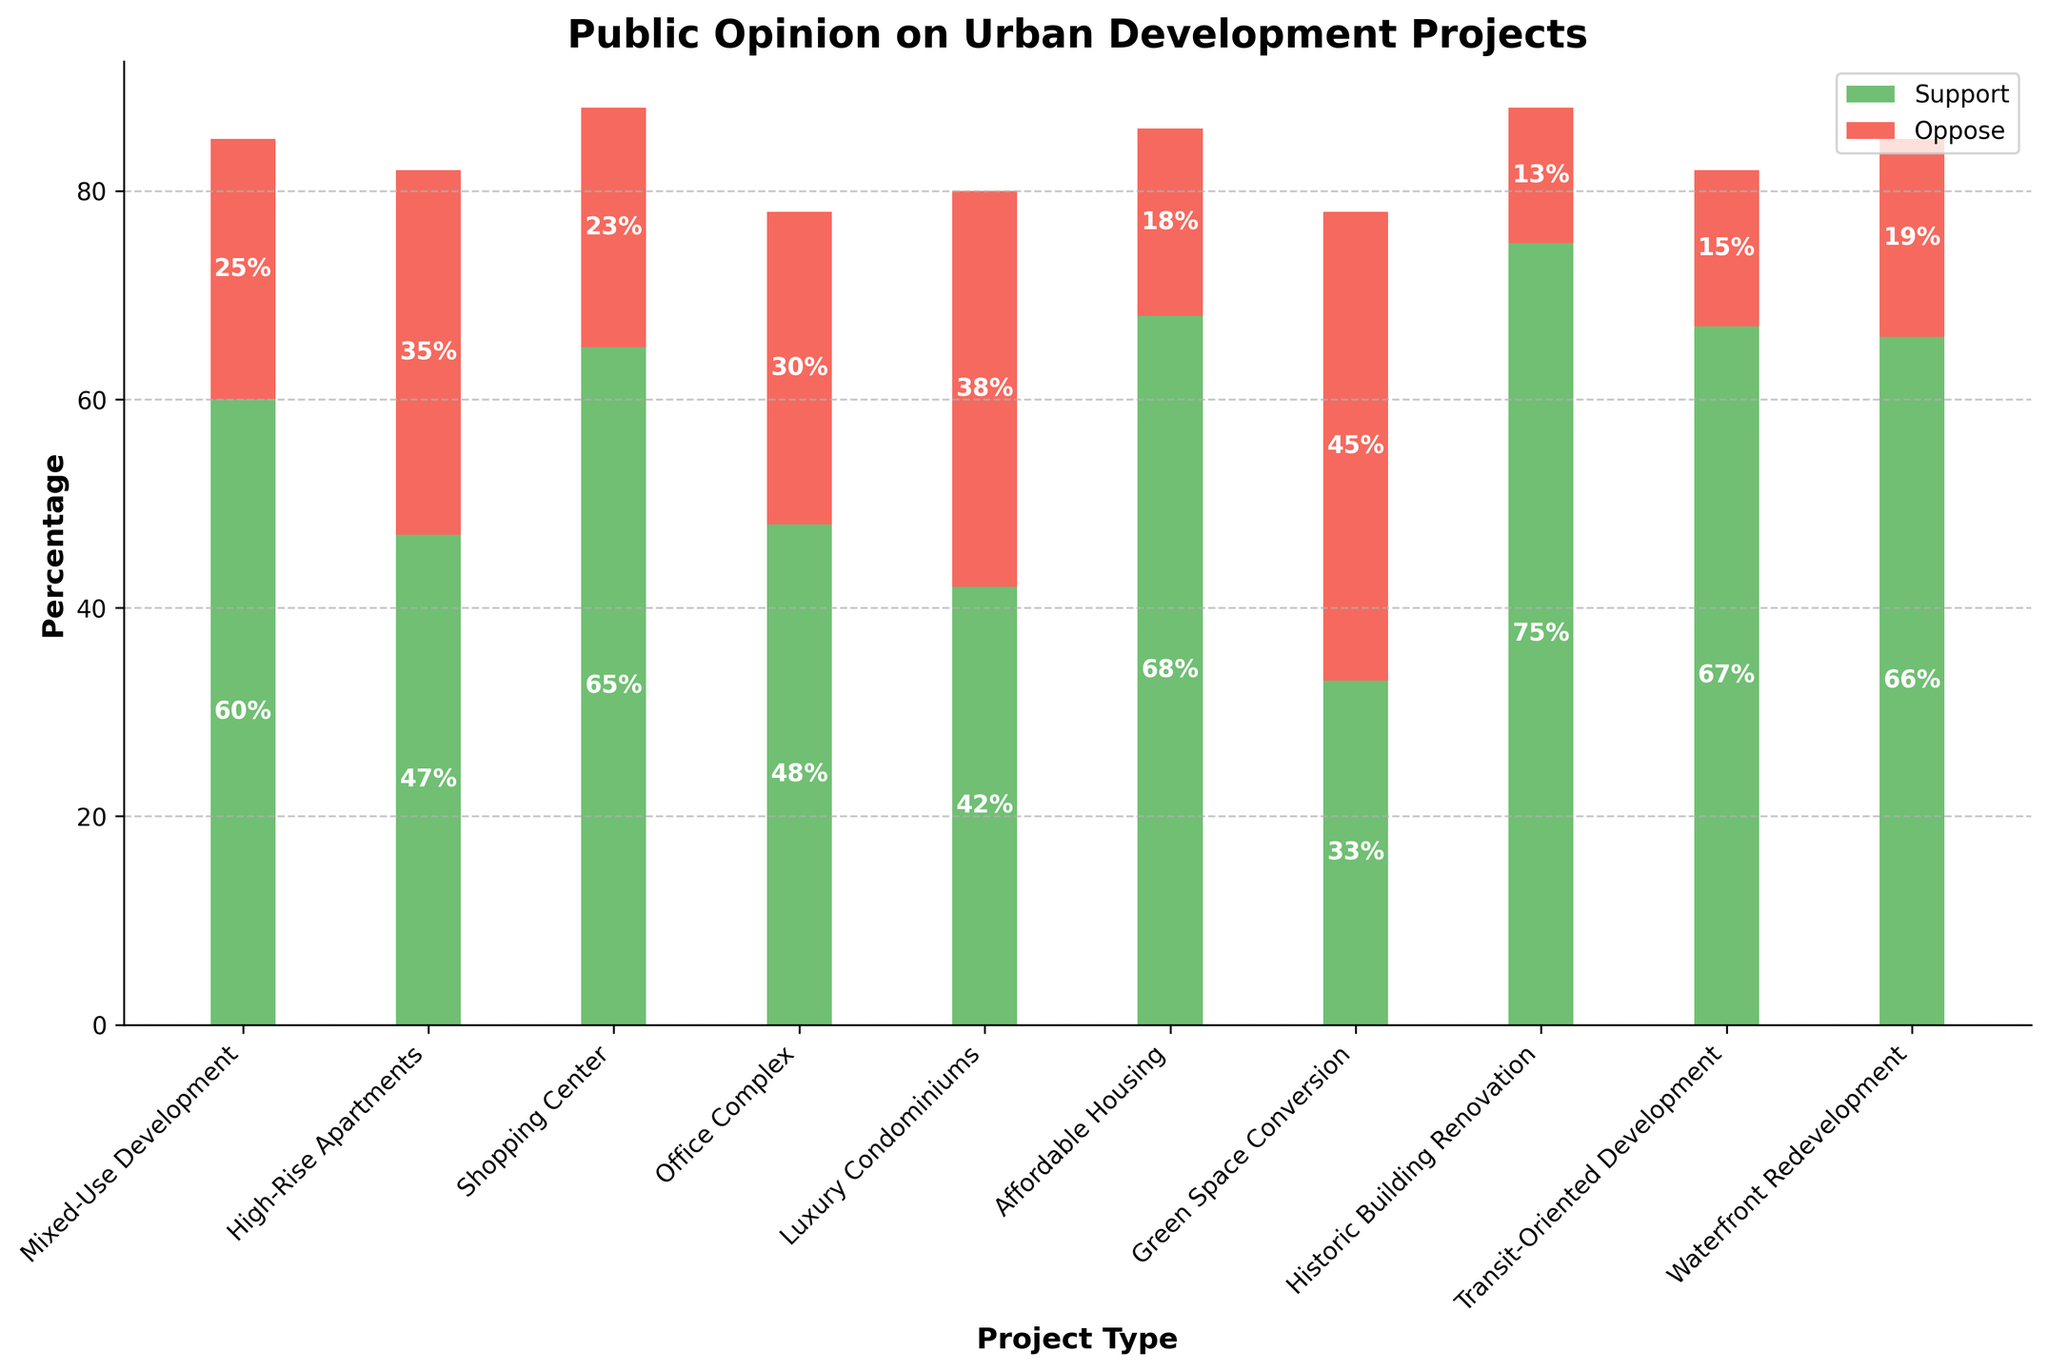Which project type has the highest percentage of strong support? To determine the project type with the highest percentage of strong support, examine the bar chart for the tallest green segment representing "Strongly Support." Historic Building Renovation shows the highest green segment.
Answer: Historic Building Renovation How much more support does Affordable Housing have compared to Mixed-Use Development? Add the "Strongly Support" and "Somewhat Support" percentages for both project types: Affordable Housing (40% + 28%) = 68% and Mixed-Use Development (28% + 32%) = 60%. The difference is 68% - 60%.
Answer: 8% Which project type has the highest combined opposition? Look for the tallest red segment representing "Somewhat Oppose" and "Strongly Oppose." Green Space Conversion shows the tallest combined red segments.
Answer: Green Space Conversion What is the difference in the total support between Transit-Oriented Development and Luxury Condominiums? Add the "Strongly Support" and "Somewhat Support" percentages for both: Transit-Oriented Development (32% + 35%) = 67% and Luxury Condominiums (18% + 24%) = 42%. The difference is 67% - 42%.
Answer: 25% Which project type has the lowest strong opposition? Find the smallest red segment representing "Strongly Oppose." Historic Building Renovation has the smallest section.
Answer: Historic Building Renovation How does the support for Waterfront Redevelopment compare to the support for a Shopping Center? Add the "Strongly Support" and "Somewhat Support" percentages: Waterfront Redevelopment (38% + 28%) = 66% and Shopping Center (35% + 30%) = 65%. Waterfront Redevelopment has 1% more support.
Answer: 1% more Which project type has more people neutral, Mixed-Use Development or High-Rise Apartments? Compare the neutral percentages: Mixed-Use Development is 15% and High-Rise Apartments is 18%. High-Rise Apartments have more neutral responses.
Answer: High-Rise Apartments What's the total percentage of opposition for Office Complex? Sum the "Somewhat Oppose" and "Strongly Oppose" percentages for Office Complex: 18% + 12%.
Answer: 30% Which project type shows the smallest total opposition? Find the smallest combined red segment for "Somewhat Oppose" and "Strongly Oppose." Transit-Oriented Development and Historic Building Renovation both have the smallest combined red segments of (10% + 5%).
Answer: Transit-Oriented Development & Historic Building Renovation What's the sum of neutral responses across all project types? Add together all the "Neutral" percentages: 15% + 18% + 12% + 22% + 20% + 14% + 22% + 12% + 18% + 15%. The total is 168%.
Answer: 168% 